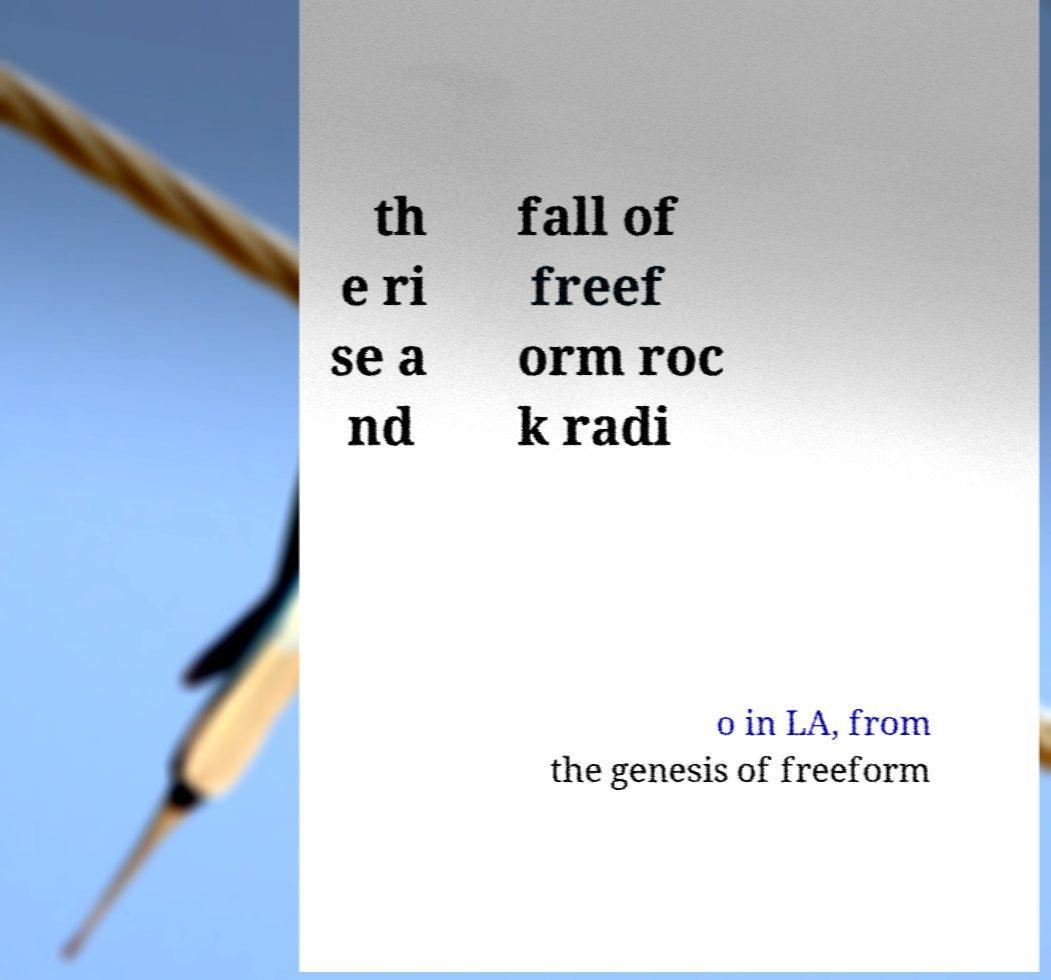Can you read and provide the text displayed in the image?This photo seems to have some interesting text. Can you extract and type it out for me? th e ri se a nd fall of freef orm roc k radi o in LA, from the genesis of freeform 